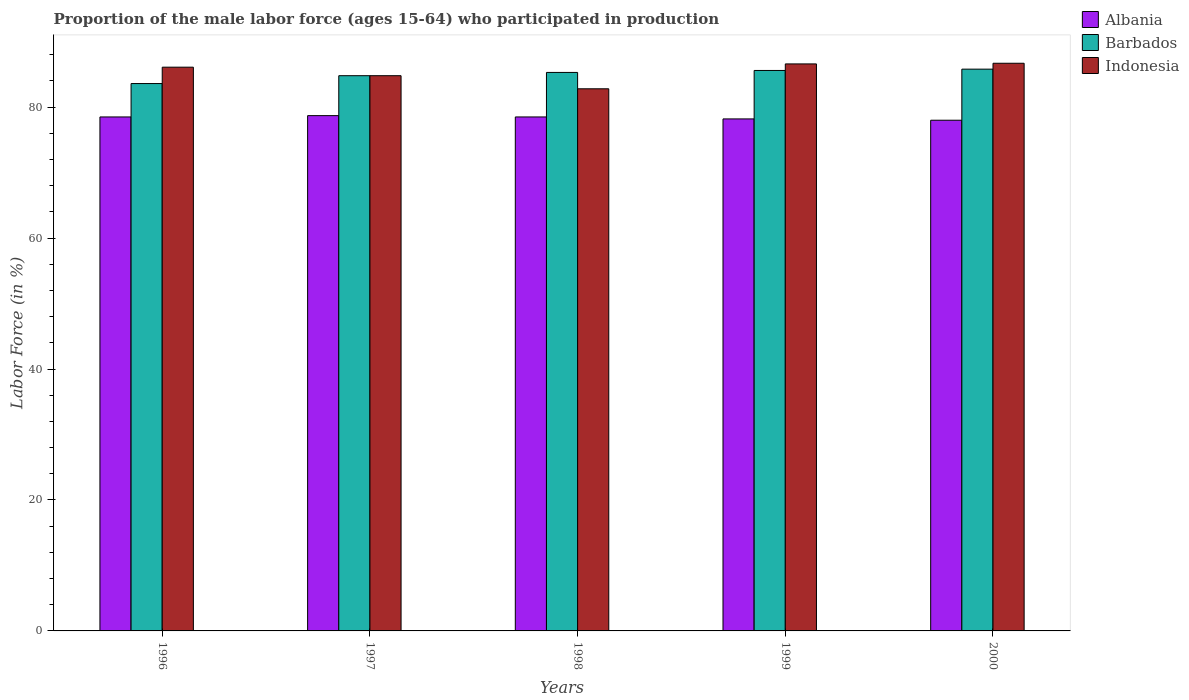Are the number of bars on each tick of the X-axis equal?
Ensure brevity in your answer.  Yes. How many bars are there on the 3rd tick from the right?
Your answer should be very brief. 3. What is the label of the 5th group of bars from the left?
Keep it short and to the point. 2000. What is the proportion of the male labor force who participated in production in Albania in 1996?
Your answer should be very brief. 78.5. Across all years, what is the maximum proportion of the male labor force who participated in production in Albania?
Your answer should be compact. 78.7. Across all years, what is the minimum proportion of the male labor force who participated in production in Barbados?
Keep it short and to the point. 83.6. In which year was the proportion of the male labor force who participated in production in Indonesia maximum?
Your answer should be very brief. 2000. In which year was the proportion of the male labor force who participated in production in Indonesia minimum?
Provide a succinct answer. 1998. What is the total proportion of the male labor force who participated in production in Albania in the graph?
Keep it short and to the point. 391.9. What is the difference between the proportion of the male labor force who participated in production in Indonesia in 1997 and that in 2000?
Provide a short and direct response. -1.9. What is the difference between the proportion of the male labor force who participated in production in Indonesia in 2000 and the proportion of the male labor force who participated in production in Albania in 1996?
Your answer should be very brief. 8.2. What is the average proportion of the male labor force who participated in production in Indonesia per year?
Make the answer very short. 85.4. In the year 1997, what is the difference between the proportion of the male labor force who participated in production in Barbados and proportion of the male labor force who participated in production in Albania?
Offer a terse response. 6.1. In how many years, is the proportion of the male labor force who participated in production in Indonesia greater than 72 %?
Your answer should be very brief. 5. What is the ratio of the proportion of the male labor force who participated in production in Albania in 1996 to that in 1997?
Your answer should be very brief. 1. What is the difference between the highest and the second highest proportion of the male labor force who participated in production in Albania?
Offer a very short reply. 0.2. What is the difference between the highest and the lowest proportion of the male labor force who participated in production in Indonesia?
Provide a succinct answer. 3.9. In how many years, is the proportion of the male labor force who participated in production in Albania greater than the average proportion of the male labor force who participated in production in Albania taken over all years?
Your answer should be compact. 3. Is the sum of the proportion of the male labor force who participated in production in Barbados in 1997 and 1998 greater than the maximum proportion of the male labor force who participated in production in Indonesia across all years?
Keep it short and to the point. Yes. What does the 1st bar from the left in 1996 represents?
Your answer should be very brief. Albania. What does the 3rd bar from the right in 1998 represents?
Your answer should be compact. Albania. Is it the case that in every year, the sum of the proportion of the male labor force who participated in production in Indonesia and proportion of the male labor force who participated in production in Albania is greater than the proportion of the male labor force who participated in production in Barbados?
Offer a terse response. Yes. How many years are there in the graph?
Offer a very short reply. 5. What is the difference between two consecutive major ticks on the Y-axis?
Make the answer very short. 20. Are the values on the major ticks of Y-axis written in scientific E-notation?
Offer a terse response. No. Does the graph contain any zero values?
Give a very brief answer. No. How many legend labels are there?
Offer a very short reply. 3. What is the title of the graph?
Keep it short and to the point. Proportion of the male labor force (ages 15-64) who participated in production. Does "Macao" appear as one of the legend labels in the graph?
Offer a terse response. No. What is the label or title of the X-axis?
Provide a succinct answer. Years. What is the label or title of the Y-axis?
Your answer should be very brief. Labor Force (in %). What is the Labor Force (in %) in Albania in 1996?
Offer a terse response. 78.5. What is the Labor Force (in %) of Barbados in 1996?
Give a very brief answer. 83.6. What is the Labor Force (in %) of Indonesia in 1996?
Your answer should be very brief. 86.1. What is the Labor Force (in %) of Albania in 1997?
Offer a terse response. 78.7. What is the Labor Force (in %) of Barbados in 1997?
Offer a terse response. 84.8. What is the Labor Force (in %) of Indonesia in 1997?
Provide a short and direct response. 84.8. What is the Labor Force (in %) of Albania in 1998?
Your answer should be compact. 78.5. What is the Labor Force (in %) in Barbados in 1998?
Keep it short and to the point. 85.3. What is the Labor Force (in %) of Indonesia in 1998?
Make the answer very short. 82.8. What is the Labor Force (in %) in Albania in 1999?
Your response must be concise. 78.2. What is the Labor Force (in %) of Barbados in 1999?
Offer a very short reply. 85.6. What is the Labor Force (in %) in Indonesia in 1999?
Your answer should be compact. 86.6. What is the Labor Force (in %) of Albania in 2000?
Your response must be concise. 78. What is the Labor Force (in %) of Barbados in 2000?
Provide a succinct answer. 85.8. What is the Labor Force (in %) of Indonesia in 2000?
Provide a short and direct response. 86.7. Across all years, what is the maximum Labor Force (in %) of Albania?
Provide a short and direct response. 78.7. Across all years, what is the maximum Labor Force (in %) of Barbados?
Provide a short and direct response. 85.8. Across all years, what is the maximum Labor Force (in %) in Indonesia?
Offer a terse response. 86.7. Across all years, what is the minimum Labor Force (in %) in Barbados?
Offer a very short reply. 83.6. Across all years, what is the minimum Labor Force (in %) in Indonesia?
Your answer should be compact. 82.8. What is the total Labor Force (in %) of Albania in the graph?
Ensure brevity in your answer.  391.9. What is the total Labor Force (in %) of Barbados in the graph?
Provide a succinct answer. 425.1. What is the total Labor Force (in %) of Indonesia in the graph?
Provide a short and direct response. 427. What is the difference between the Labor Force (in %) in Albania in 1996 and that in 1997?
Your response must be concise. -0.2. What is the difference between the Labor Force (in %) of Barbados in 1996 and that in 1997?
Offer a very short reply. -1.2. What is the difference between the Labor Force (in %) in Albania in 1996 and that in 1998?
Keep it short and to the point. 0. What is the difference between the Labor Force (in %) in Indonesia in 1996 and that in 1999?
Provide a short and direct response. -0.5. What is the difference between the Labor Force (in %) in Indonesia in 1997 and that in 1998?
Provide a succinct answer. 2. What is the difference between the Labor Force (in %) in Indonesia in 1997 and that in 1999?
Your response must be concise. -1.8. What is the difference between the Labor Force (in %) in Albania in 1998 and that in 1999?
Ensure brevity in your answer.  0.3. What is the difference between the Labor Force (in %) in Barbados in 1998 and that in 1999?
Your answer should be very brief. -0.3. What is the difference between the Labor Force (in %) in Indonesia in 1998 and that in 1999?
Ensure brevity in your answer.  -3.8. What is the difference between the Labor Force (in %) in Barbados in 1999 and that in 2000?
Provide a succinct answer. -0.2. What is the difference between the Labor Force (in %) of Barbados in 1996 and the Labor Force (in %) of Indonesia in 1997?
Offer a very short reply. -1.2. What is the difference between the Labor Force (in %) of Albania in 1996 and the Labor Force (in %) of Barbados in 1998?
Offer a terse response. -6.8. What is the difference between the Labor Force (in %) of Albania in 1996 and the Labor Force (in %) of Indonesia in 1998?
Ensure brevity in your answer.  -4.3. What is the difference between the Labor Force (in %) of Barbados in 1996 and the Labor Force (in %) of Indonesia in 1998?
Make the answer very short. 0.8. What is the difference between the Labor Force (in %) of Albania in 1996 and the Labor Force (in %) of Barbados in 1999?
Offer a very short reply. -7.1. What is the difference between the Labor Force (in %) of Albania in 1996 and the Labor Force (in %) of Indonesia in 1999?
Give a very brief answer. -8.1. What is the difference between the Labor Force (in %) in Barbados in 1996 and the Labor Force (in %) in Indonesia in 1999?
Your response must be concise. -3. What is the difference between the Labor Force (in %) of Albania in 1996 and the Labor Force (in %) of Barbados in 2000?
Offer a terse response. -7.3. What is the difference between the Labor Force (in %) in Albania in 1996 and the Labor Force (in %) in Indonesia in 2000?
Your response must be concise. -8.2. What is the difference between the Labor Force (in %) of Albania in 1997 and the Labor Force (in %) of Indonesia in 1998?
Offer a very short reply. -4.1. What is the difference between the Labor Force (in %) in Barbados in 1997 and the Labor Force (in %) in Indonesia in 1998?
Your answer should be compact. 2. What is the difference between the Labor Force (in %) of Albania in 1997 and the Labor Force (in %) of Indonesia in 1999?
Your response must be concise. -7.9. What is the difference between the Labor Force (in %) of Barbados in 1997 and the Labor Force (in %) of Indonesia in 1999?
Ensure brevity in your answer.  -1.8. What is the difference between the Labor Force (in %) of Albania in 1997 and the Labor Force (in %) of Barbados in 2000?
Give a very brief answer. -7.1. What is the difference between the Labor Force (in %) of Barbados in 1997 and the Labor Force (in %) of Indonesia in 2000?
Offer a terse response. -1.9. What is the difference between the Labor Force (in %) in Albania in 1998 and the Labor Force (in %) in Barbados in 1999?
Offer a terse response. -7.1. What is the difference between the Labor Force (in %) in Albania in 1998 and the Labor Force (in %) in Indonesia in 1999?
Make the answer very short. -8.1. What is the difference between the Labor Force (in %) in Barbados in 1998 and the Labor Force (in %) in Indonesia in 1999?
Your answer should be compact. -1.3. What is the difference between the Labor Force (in %) of Albania in 1998 and the Labor Force (in %) of Barbados in 2000?
Your answer should be very brief. -7.3. What is the difference between the Labor Force (in %) of Barbados in 1998 and the Labor Force (in %) of Indonesia in 2000?
Make the answer very short. -1.4. What is the difference between the Labor Force (in %) in Barbados in 1999 and the Labor Force (in %) in Indonesia in 2000?
Your answer should be compact. -1.1. What is the average Labor Force (in %) in Albania per year?
Ensure brevity in your answer.  78.38. What is the average Labor Force (in %) in Barbados per year?
Provide a short and direct response. 85.02. What is the average Labor Force (in %) in Indonesia per year?
Your answer should be compact. 85.4. In the year 1996, what is the difference between the Labor Force (in %) in Barbados and Labor Force (in %) in Indonesia?
Ensure brevity in your answer.  -2.5. In the year 1997, what is the difference between the Labor Force (in %) in Albania and Labor Force (in %) in Barbados?
Your answer should be compact. -6.1. In the year 1997, what is the difference between the Labor Force (in %) in Barbados and Labor Force (in %) in Indonesia?
Your response must be concise. 0. In the year 1998, what is the difference between the Labor Force (in %) of Albania and Labor Force (in %) of Indonesia?
Keep it short and to the point. -4.3. In the year 1999, what is the difference between the Labor Force (in %) in Albania and Labor Force (in %) in Barbados?
Offer a very short reply. -7.4. In the year 2000, what is the difference between the Labor Force (in %) of Albania and Labor Force (in %) of Indonesia?
Give a very brief answer. -8.7. What is the ratio of the Labor Force (in %) in Barbados in 1996 to that in 1997?
Give a very brief answer. 0.99. What is the ratio of the Labor Force (in %) of Indonesia in 1996 to that in 1997?
Offer a terse response. 1.02. What is the ratio of the Labor Force (in %) of Barbados in 1996 to that in 1998?
Your answer should be compact. 0.98. What is the ratio of the Labor Force (in %) of Indonesia in 1996 to that in 1998?
Make the answer very short. 1.04. What is the ratio of the Labor Force (in %) of Albania in 1996 to that in 1999?
Give a very brief answer. 1. What is the ratio of the Labor Force (in %) in Barbados in 1996 to that in 1999?
Your response must be concise. 0.98. What is the ratio of the Labor Force (in %) in Albania in 1996 to that in 2000?
Provide a succinct answer. 1.01. What is the ratio of the Labor Force (in %) in Barbados in 1996 to that in 2000?
Offer a very short reply. 0.97. What is the ratio of the Labor Force (in %) in Indonesia in 1996 to that in 2000?
Keep it short and to the point. 0.99. What is the ratio of the Labor Force (in %) of Albania in 1997 to that in 1998?
Provide a short and direct response. 1. What is the ratio of the Labor Force (in %) in Barbados in 1997 to that in 1998?
Your answer should be compact. 0.99. What is the ratio of the Labor Force (in %) in Indonesia in 1997 to that in 1998?
Your answer should be very brief. 1.02. What is the ratio of the Labor Force (in %) of Albania in 1997 to that in 1999?
Keep it short and to the point. 1.01. What is the ratio of the Labor Force (in %) of Indonesia in 1997 to that in 1999?
Ensure brevity in your answer.  0.98. What is the ratio of the Labor Force (in %) in Barbados in 1997 to that in 2000?
Keep it short and to the point. 0.99. What is the ratio of the Labor Force (in %) of Indonesia in 1997 to that in 2000?
Keep it short and to the point. 0.98. What is the ratio of the Labor Force (in %) in Albania in 1998 to that in 1999?
Offer a terse response. 1. What is the ratio of the Labor Force (in %) of Indonesia in 1998 to that in 1999?
Offer a very short reply. 0.96. What is the ratio of the Labor Force (in %) in Albania in 1998 to that in 2000?
Keep it short and to the point. 1.01. What is the ratio of the Labor Force (in %) of Indonesia in 1998 to that in 2000?
Provide a short and direct response. 0.95. What is the ratio of the Labor Force (in %) in Albania in 1999 to that in 2000?
Keep it short and to the point. 1. What is the difference between the highest and the second highest Labor Force (in %) in Barbados?
Make the answer very short. 0.2. What is the difference between the highest and the lowest Labor Force (in %) of Indonesia?
Your response must be concise. 3.9. 